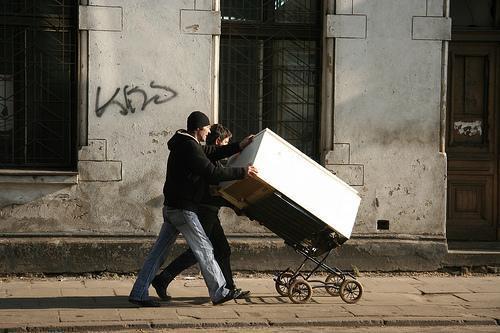How many people are in this picture?
Give a very brief answer. 2. How many people are riding bicycle on the road?
Give a very brief answer. 0. How many people are wearing a hat!?
Give a very brief answer. 1. 